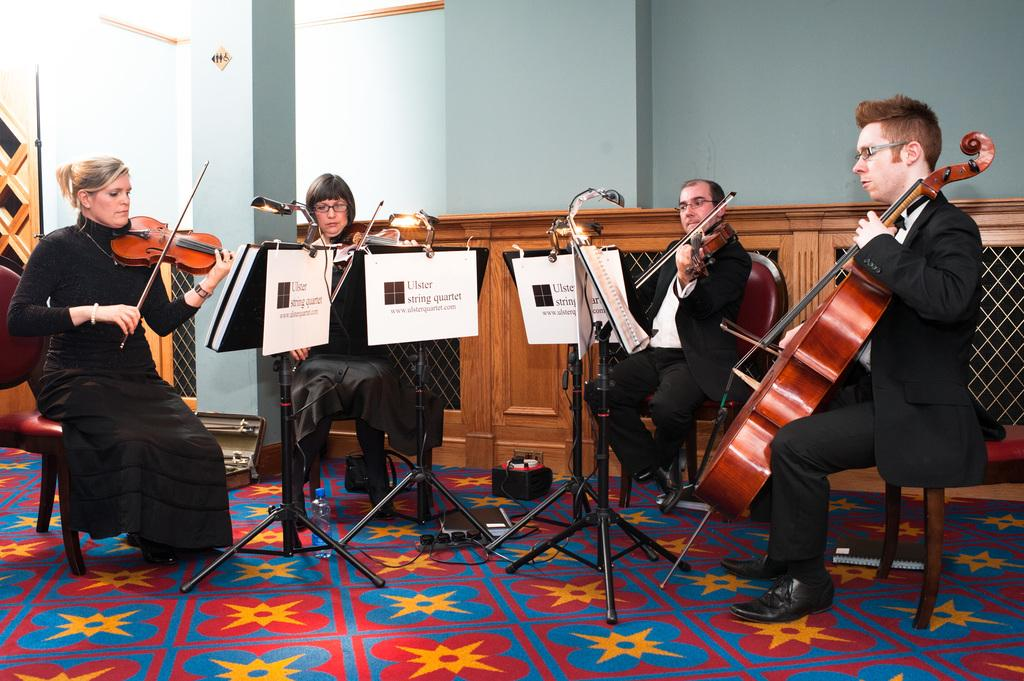What are the persons in the image doing? The persons in the image are playing guitars. What are the persons sitting on while playing guitars? The persons are sitting on chairs. What type of surface is visible beneath the chairs? There is a floor visible in the image. What can be seen behind the persons in the image? There is a wall in the image. Are there any architectural features in the image besides the wall? Yes, there is a pillar in the image. What type of table is being used to hold the hose in the image? There is no table or hose present in the image; the focus is on the persons playing guitars and the surrounding architectural features. 